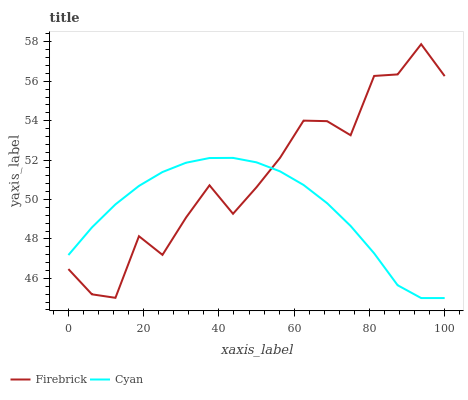Does Cyan have the minimum area under the curve?
Answer yes or no. Yes. Does Firebrick have the maximum area under the curve?
Answer yes or no. Yes. Does Firebrick have the minimum area under the curve?
Answer yes or no. No. Is Cyan the smoothest?
Answer yes or no. Yes. Is Firebrick the roughest?
Answer yes or no. Yes. Is Firebrick the smoothest?
Answer yes or no. No. Does Cyan have the lowest value?
Answer yes or no. Yes. Does Firebrick have the lowest value?
Answer yes or no. No. Does Firebrick have the highest value?
Answer yes or no. Yes. Does Cyan intersect Firebrick?
Answer yes or no. Yes. Is Cyan less than Firebrick?
Answer yes or no. No. Is Cyan greater than Firebrick?
Answer yes or no. No. 